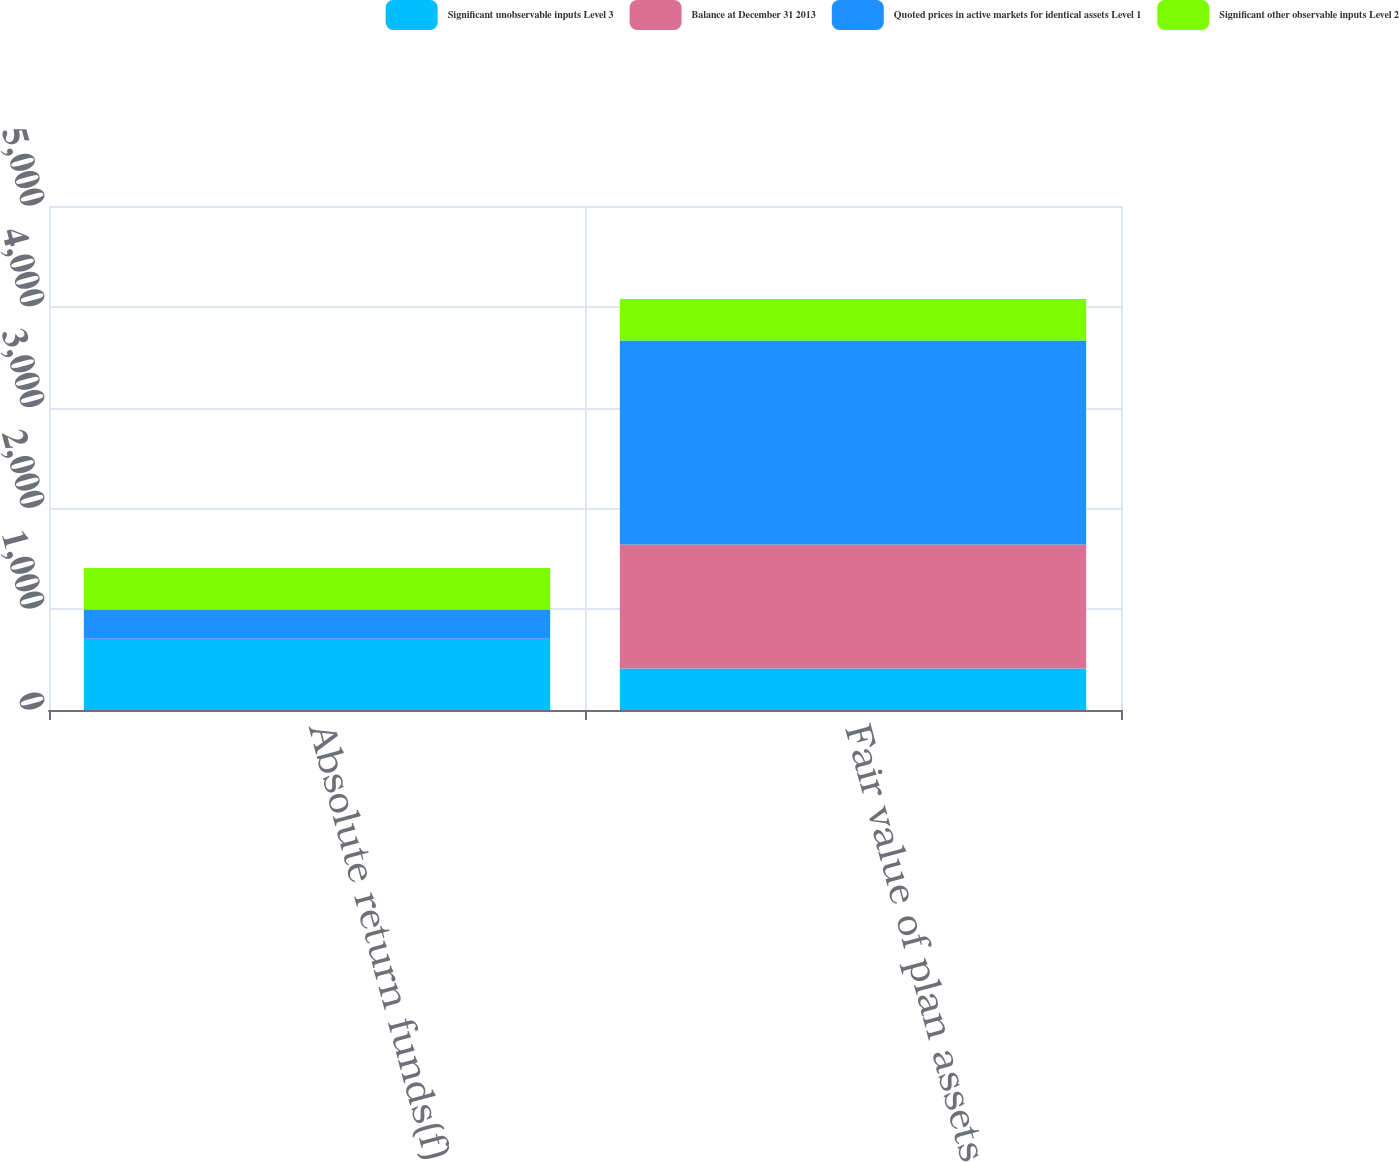<chart> <loc_0><loc_0><loc_500><loc_500><stacked_bar_chart><ecel><fcel>Absolute return funds(f)<fcel>Fair value of plan assets<nl><fcel>Significant unobservable inputs Level 3<fcel>704<fcel>411<nl><fcel>Balance at December 31 2013<fcel>3<fcel>1232<nl><fcel>Quoted prices in active markets for identical assets Level 1<fcel>290<fcel>2023<nl><fcel>Significant other observable inputs Level 2<fcel>411<fcel>411<nl></chart> 